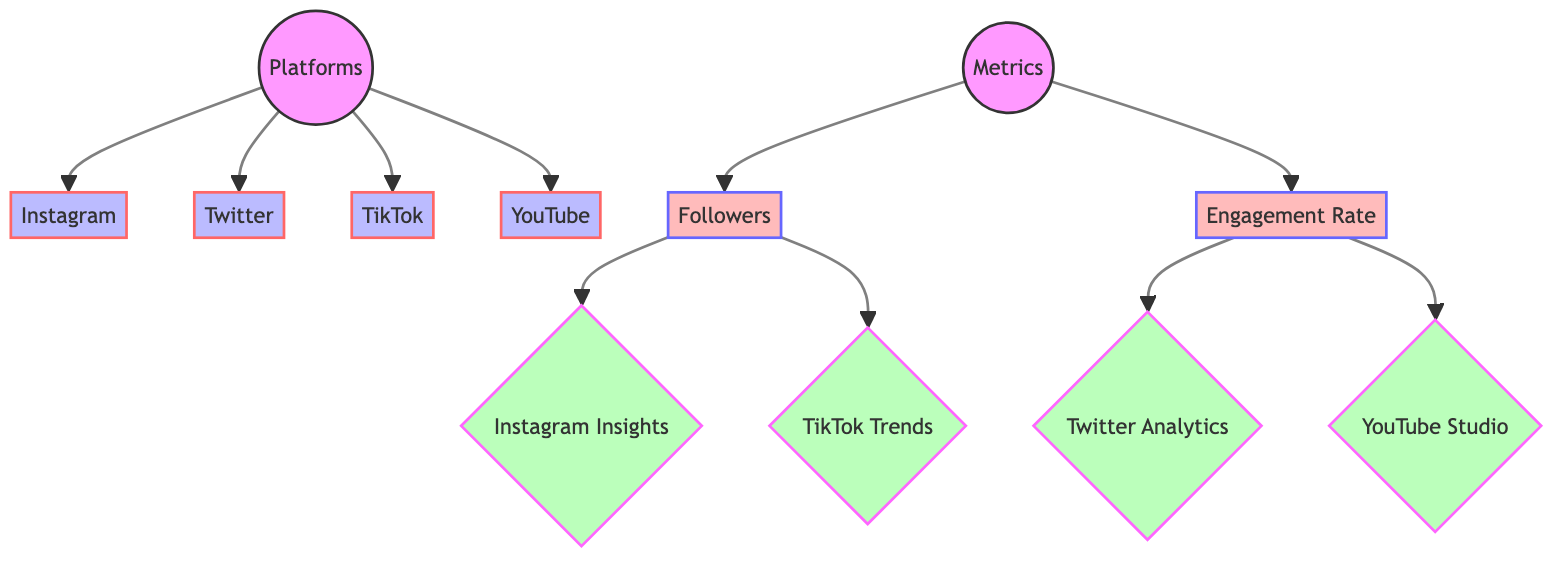What platforms are included in the diagram? The diagram lists four platforms connected to the central node labeled "Platforms." They are Instagram, Twitter, TikTok, and YouTube, which can be seen as individual nodes branching out from the main platform node.
Answer: Instagram, Twitter, TikTok, YouTube How many metrics are shown in the diagram? The diagram has two main metrics connected to the node labeled "Metrics": Followers and Engagement Rate. Each metric is linked to insights that provide data for analysis. Counting the two metrics gives the total.
Answer: 2 Which insights are associated with the Followers metric? The Followers metric branches into additional nodes, specifically Instagram Insights and TikTok Trends, giving insights into this particular metric. By following the link from the Followers node, you can see these two insights clearly.
Answer: Instagram Insights, TikTok Trends What is the relationship between Engagement Rate and its associated insights? The Engagement Rate node connects to two insights: Twitter Analytics and YouTube Studio. This demonstrates that these platforms provide relevant data or analytics for analyzing engagement rates. The relationship shows how Engagement Rate is supported by these specific tools.
Answer: Twitter Analytics, YouTube Studio Which platform has insight connected for both followers and engagement? By reviewing the connections, Instagram is the only platform with insights linked to the Followers metric. However, for engagement, it is not included, as the Engagement Rate connects to different analytics (Twitter and YouTube). Thus, the answer would refer to the insights based on two metrics.
Answer: None 